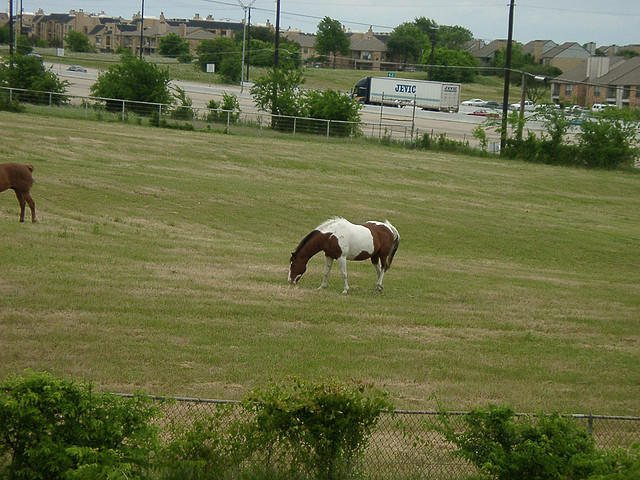Read and extract the text from this image. JEVIC 